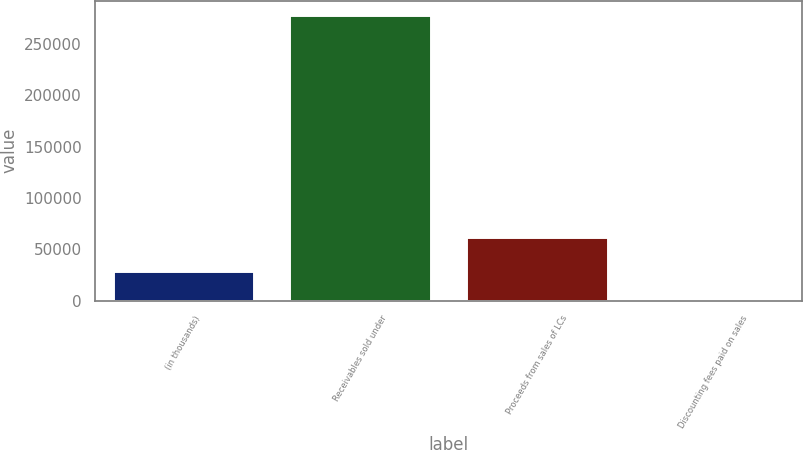Convert chart to OTSL. <chart><loc_0><loc_0><loc_500><loc_500><bar_chart><fcel>(in thousands)<fcel>Receivables sold under<fcel>Proceeds from sales of LCs<fcel>Discounting fees paid on sales<nl><fcel>28579.6<fcel>278560<fcel>61850<fcel>804<nl></chart> 